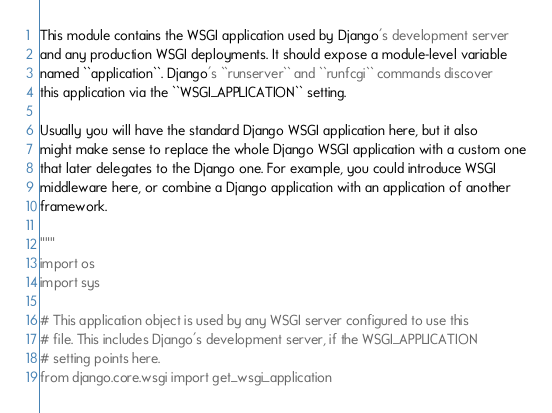Convert code to text. <code><loc_0><loc_0><loc_500><loc_500><_Python_>
This module contains the WSGI application used by Django's development server
and any production WSGI deployments. It should expose a module-level variable
named ``application``. Django's ``runserver`` and ``runfcgi`` commands discover
this application via the ``WSGI_APPLICATION`` setting.

Usually you will have the standard Django WSGI application here, but it also
might make sense to replace the whole Django WSGI application with a custom one
that later delegates to the Django one. For example, you could introduce WSGI
middleware here, or combine a Django application with an application of another
framework.

"""
import os
import sys

# This application object is used by any WSGI server configured to use this
# file. This includes Django's development server, if the WSGI_APPLICATION
# setting points here.
from django.core.wsgi import get_wsgi_application
</code> 